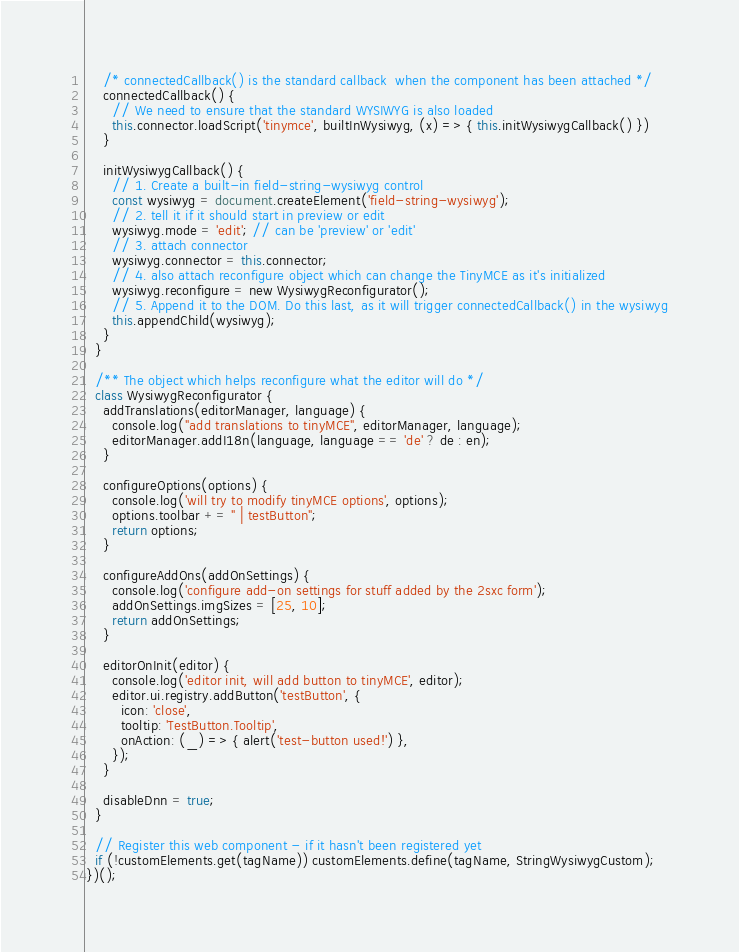Convert code to text. <code><loc_0><loc_0><loc_500><loc_500><_JavaScript_>    /* connectedCallback() is the standard callback  when the component has been attached */
    connectedCallback() {
      // We need to ensure that the standard WYSIWYG is also loaded
      this.connector.loadScript('tinymce', builtInWysiwyg, (x) => { this.initWysiwygCallback() })
    }

    initWysiwygCallback() {
      // 1. Create a built-in field-string-wysiwyg control
      const wysiwyg = document.createElement('field-string-wysiwyg');
      // 2. tell it if it should start in preview or edit
      wysiwyg.mode = 'edit'; // can be 'preview' or 'edit'
      // 3. attach connector
      wysiwyg.connector = this.connector;
      // 4. also attach reconfigure object which can change the TinyMCE as it's initialized
      wysiwyg.reconfigure = new WysiwygReconfigurator();
      // 5. Append it to the DOM. Do this last, as it will trigger connectedCallback() in the wysiwyg
      this.appendChild(wysiwyg);
    }
  }

  /** The object which helps reconfigure what the editor will do */
  class WysiwygReconfigurator {
    addTranslations(editorManager, language) {
      console.log("add translations to tinyMCE", editorManager, language);
      editorManager.addI18n(language, language == 'de' ? de : en);
    }

    configureOptions(options) {
      console.log('will try to modify tinyMCE options', options);
      options.toolbar += " | testButton";
      return options;
    }

    configureAddOns(addOnSettings) {
      console.log('configure add-on settings for stuff added by the 2sxc form');
      addOnSettings.imgSizes = [25, 10];
      return addOnSettings;
    }

    editorOnInit(editor) {
      console.log('editor init, will add button to tinyMCE', editor);
      editor.ui.registry.addButton('testButton', {
        icon: 'close',
        tooltip: 'TestButton.Tooltip',
        onAction: (_) => { alert('test-button used!') },
      });
    }

    disableDnn = true;
  }

  // Register this web component - if it hasn't been registered yet
  if (!customElements.get(tagName)) customElements.define(tagName, StringWysiwygCustom);
})();</code> 